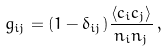Convert formula to latex. <formula><loc_0><loc_0><loc_500><loc_500>g _ { i j } = ( 1 - \delta _ { i j } ) \frac { \left < c _ { i } c _ { j } \right > } { n _ { i } n _ { j } } \, ,</formula> 